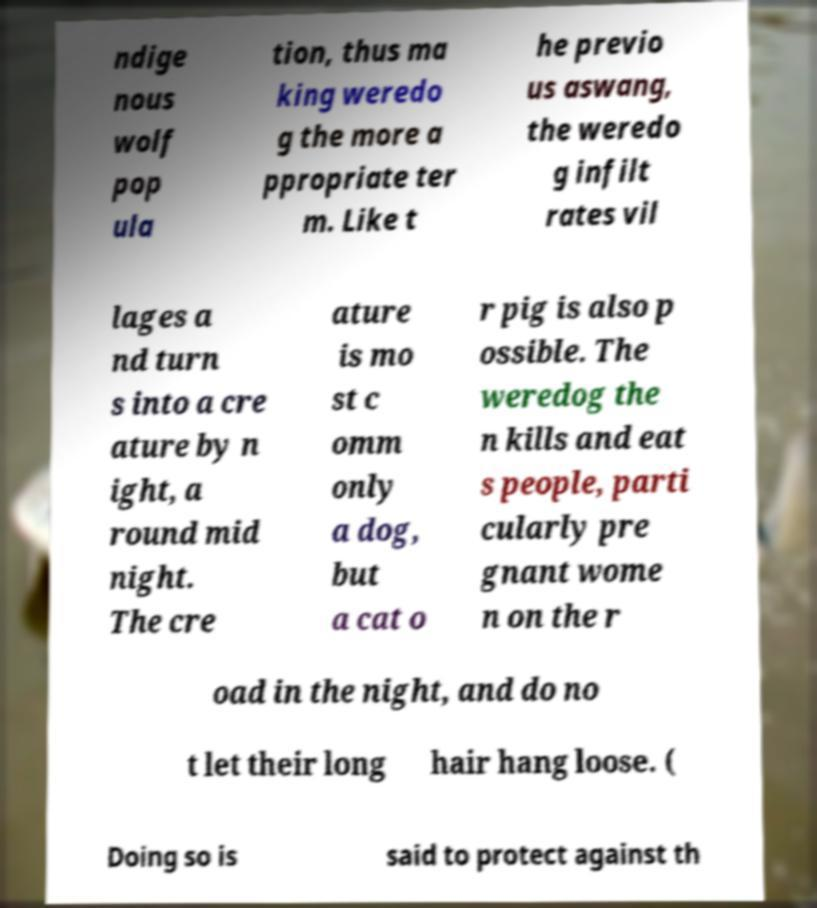Can you read and provide the text displayed in the image?This photo seems to have some interesting text. Can you extract and type it out for me? ndige nous wolf pop ula tion, thus ma king weredo g the more a ppropriate ter m. Like t he previo us aswang, the weredo g infilt rates vil lages a nd turn s into a cre ature by n ight, a round mid night. The cre ature is mo st c omm only a dog, but a cat o r pig is also p ossible. The weredog the n kills and eat s people, parti cularly pre gnant wome n on the r oad in the night, and do no t let their long hair hang loose. ( Doing so is said to protect against th 